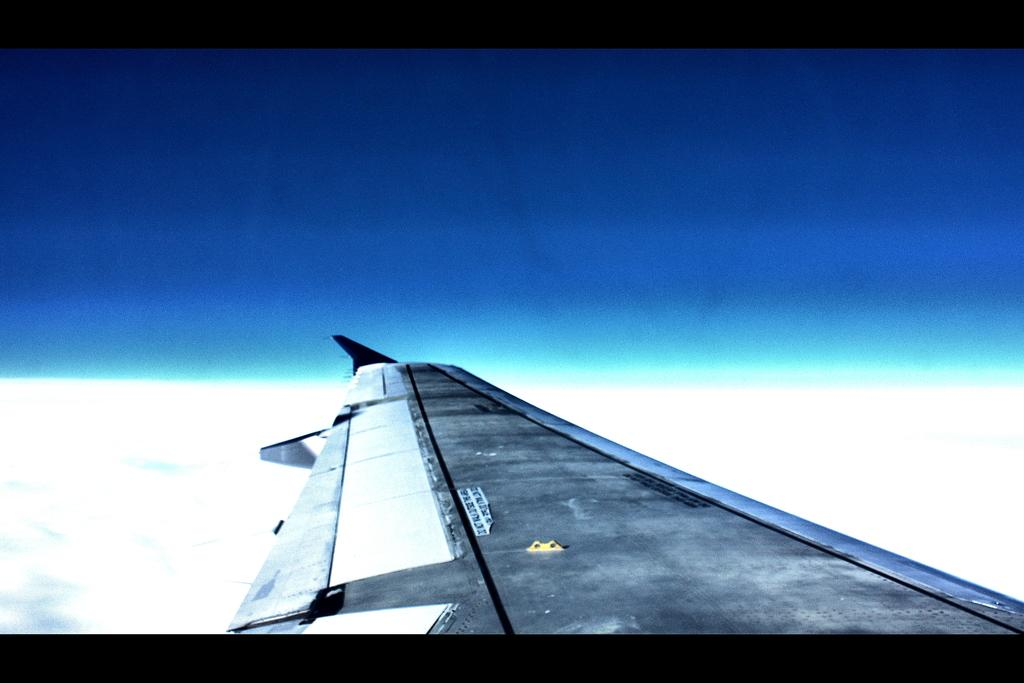What is the main subject of the image? The main subject of the image is a wing of an airplane. Where is the wing located in the image? The wing is at the bottom of the image. What can be seen in the background of the image? There is a sky visible in the background of the image. What type of joke can be heard in the image? There is no joke present in the image; it features a wing of an airplane. How many snakes are slithering on the wing in the image? There are no snakes present in the image; it features a wing of an airplane. 